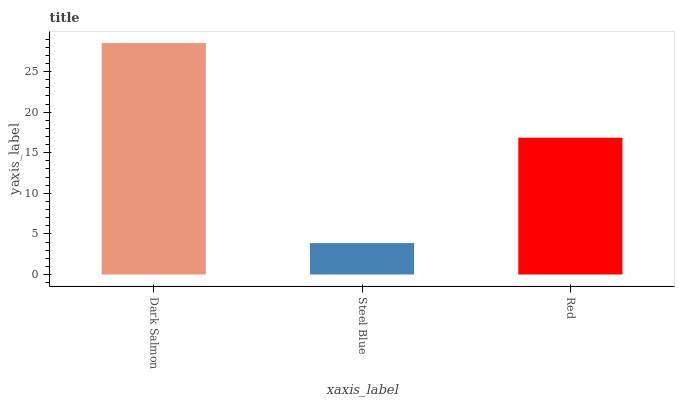Is Steel Blue the minimum?
Answer yes or no. Yes. Is Dark Salmon the maximum?
Answer yes or no. Yes. Is Red the minimum?
Answer yes or no. No. Is Red the maximum?
Answer yes or no. No. Is Red greater than Steel Blue?
Answer yes or no. Yes. Is Steel Blue less than Red?
Answer yes or no. Yes. Is Steel Blue greater than Red?
Answer yes or no. No. Is Red less than Steel Blue?
Answer yes or no. No. Is Red the high median?
Answer yes or no. Yes. Is Red the low median?
Answer yes or no. Yes. Is Dark Salmon the high median?
Answer yes or no. No. Is Dark Salmon the low median?
Answer yes or no. No. 